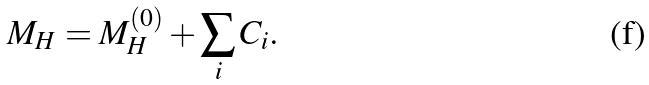<formula> <loc_0><loc_0><loc_500><loc_500>M _ { H } = M _ { H } ^ { ( 0 ) } + \sum _ { i } C _ { i } .</formula> 